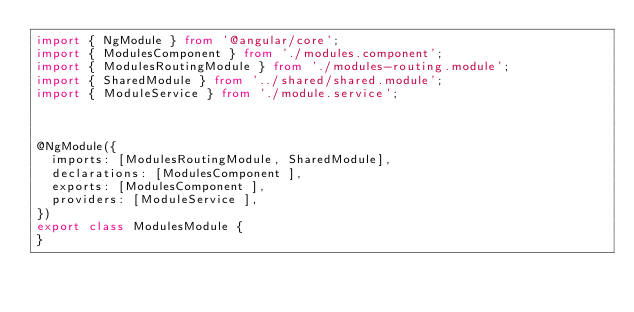Convert code to text. <code><loc_0><loc_0><loc_500><loc_500><_TypeScript_>import { NgModule } from '@angular/core';
import { ModulesComponent } from './modules.component';
import { ModulesRoutingModule } from './modules-routing.module';
import { SharedModule } from '../shared/shared.module';
import { ModuleService } from './module.service';



@NgModule({
  imports: [ModulesRoutingModule, SharedModule],
  declarations: [ModulesComponent ],
  exports: [ModulesComponent ],
  providers: [ModuleService ],
})
export class ModulesModule {
}
</code> 